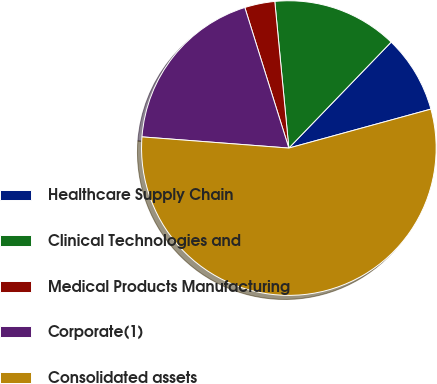Convert chart to OTSL. <chart><loc_0><loc_0><loc_500><loc_500><pie_chart><fcel>Healthcare Supply Chain<fcel>Clinical Technologies and<fcel>Medical Products Manufacturing<fcel>Corporate(1)<fcel>Consolidated assets<nl><fcel>8.52%<fcel>13.74%<fcel>3.31%<fcel>18.96%<fcel>55.47%<nl></chart> 